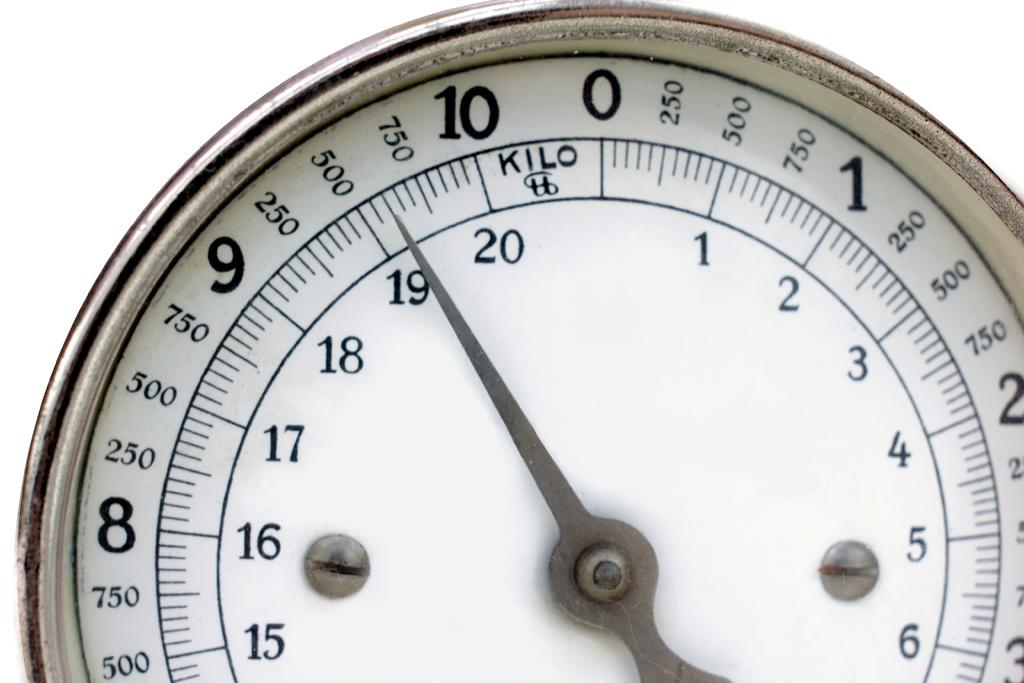<image>
Render a clear and concise summary of the photo. A scale shows a weight reading of of 600 kilos. 